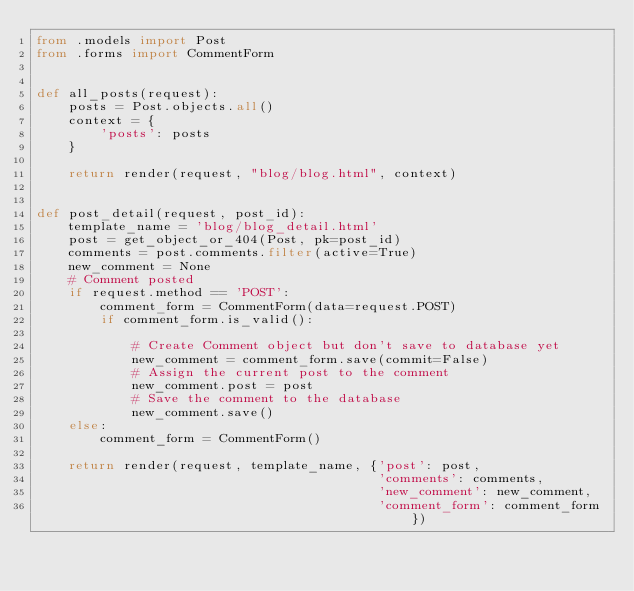<code> <loc_0><loc_0><loc_500><loc_500><_Python_>from .models import Post
from .forms import CommentForm


def all_posts(request):
    posts = Post.objects.all()
    context = {
        'posts': posts
    }

    return render(request, "blog/blog.html", context)


def post_detail(request, post_id):
    template_name = 'blog/blog_detail.html'
    post = get_object_or_404(Post, pk=post_id)
    comments = post.comments.filter(active=True)
    new_comment = None
    # Comment posted
    if request.method == 'POST':
        comment_form = CommentForm(data=request.POST)
        if comment_form.is_valid():

            # Create Comment object but don't save to database yet
            new_comment = comment_form.save(commit=False)
            # Assign the current post to the comment
            new_comment.post = post
            # Save the comment to the database
            new_comment.save()
    else:
        comment_form = CommentForm()

    return render(request, template_name, {'post': post,
                                           'comments': comments,
                                           'new_comment': new_comment,
                                           'comment_form': comment_form})
</code> 